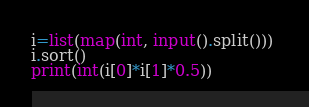Convert code to text. <code><loc_0><loc_0><loc_500><loc_500><_Python_>i=list(map(int, input().split())) 
i.sort()
print(int(i[0]*i[1]*0.5))</code> 